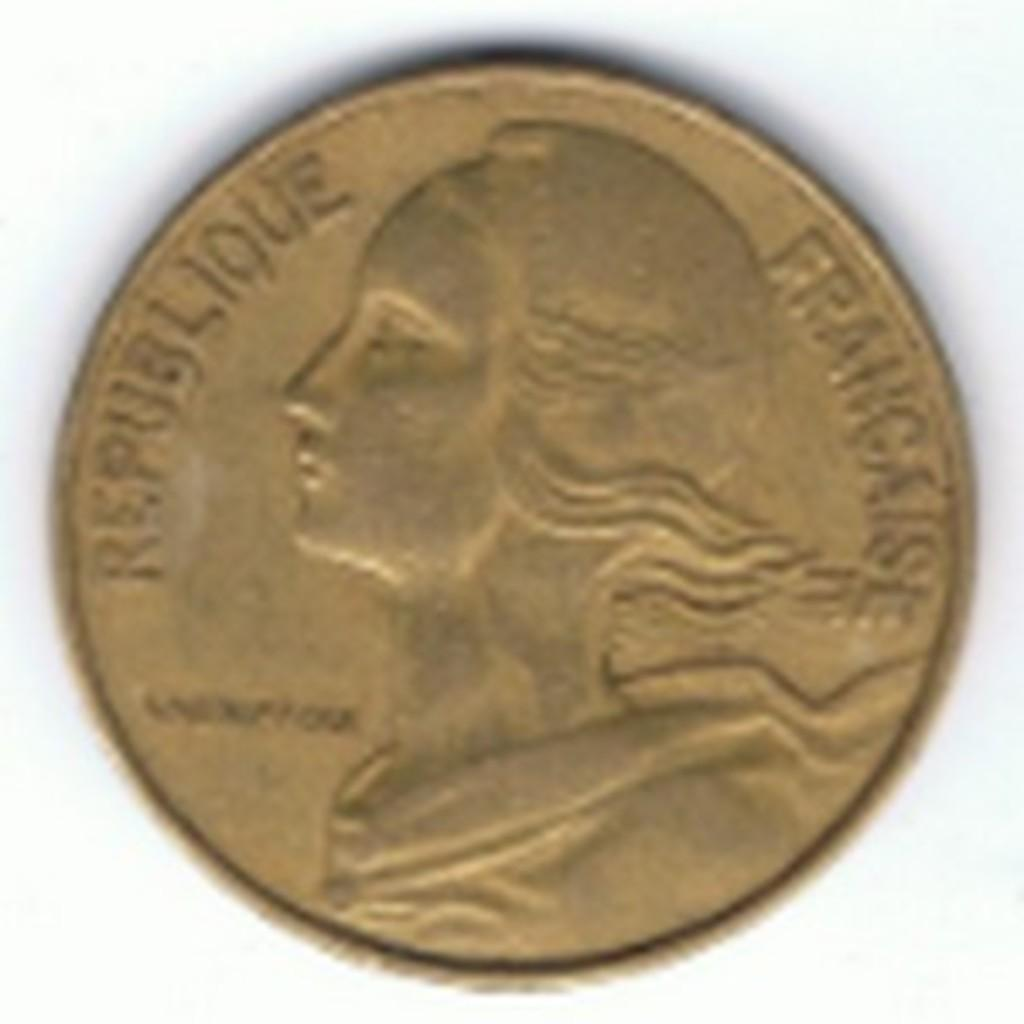Provide a one-sentence caption for the provided image. A historical coin originating from France that shows visible signs of wear. 